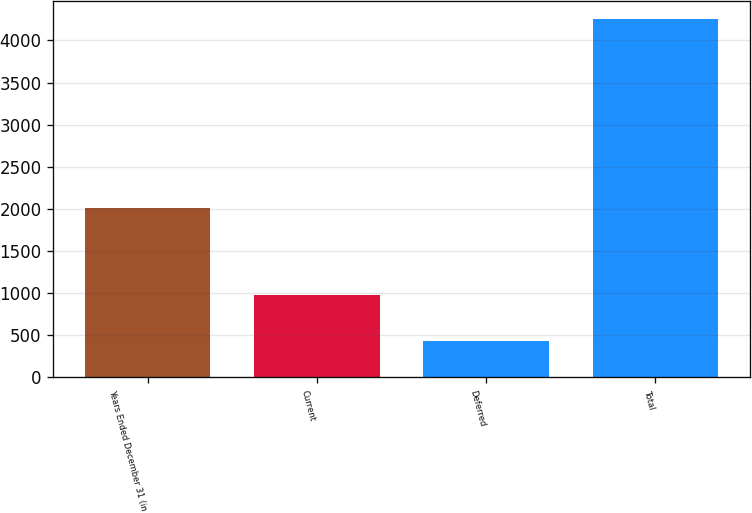Convert chart. <chart><loc_0><loc_0><loc_500><loc_500><bar_chart><fcel>Years Ended December 31 (in<fcel>Current<fcel>Deferred<fcel>Total<nl><fcel>2005<fcel>974<fcel>426<fcel>4258<nl></chart> 